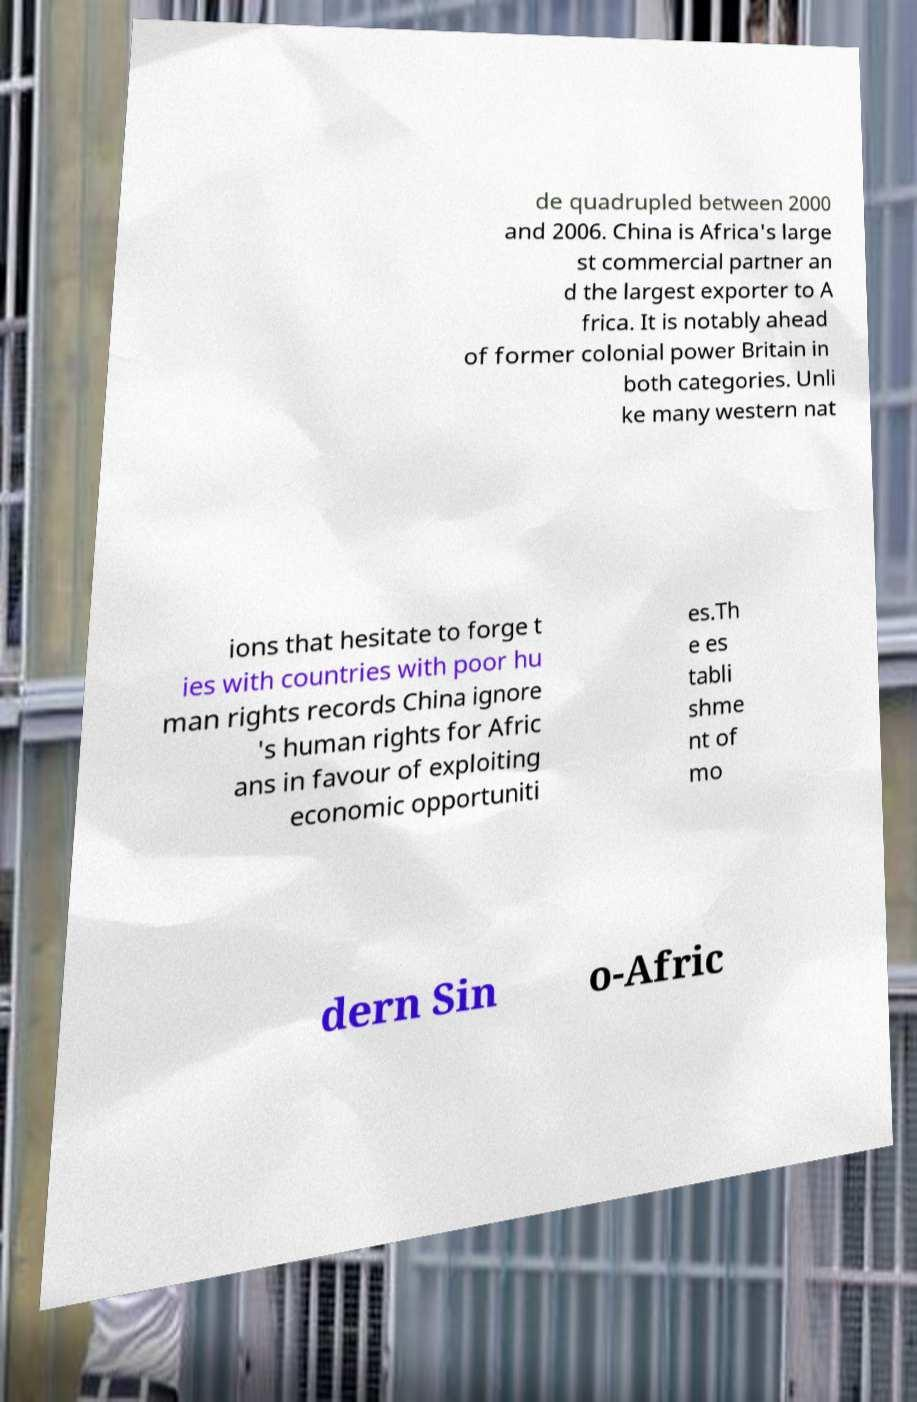Please read and relay the text visible in this image. What does it say? de quadrupled between 2000 and 2006. China is Africa's large st commercial partner an d the largest exporter to A frica. It is notably ahead of former colonial power Britain in both categories. Unli ke many western nat ions that hesitate to forge t ies with countries with poor hu man rights records China ignore 's human rights for Afric ans in favour of exploiting economic opportuniti es.Th e es tabli shme nt of mo dern Sin o-Afric 